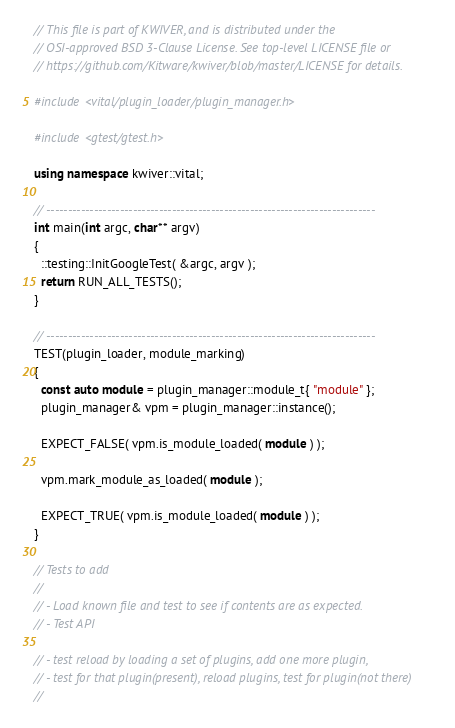<code> <loc_0><loc_0><loc_500><loc_500><_C++_>// This file is part of KWIVER, and is distributed under the
// OSI-approved BSD 3-Clause License. See top-level LICENSE file or
// https://github.com/Kitware/kwiver/blob/master/LICENSE for details.

#include <vital/plugin_loader/plugin_manager.h>

#include <gtest/gtest.h>

using namespace kwiver::vital;

// ----------------------------------------------------------------------------
int main(int argc, char** argv)
{
  ::testing::InitGoogleTest( &argc, argv );
  return RUN_ALL_TESTS();
}

// ----------------------------------------------------------------------------
TEST(plugin_loader, module_marking)
{
  const auto module = plugin_manager::module_t{ "module" };
  plugin_manager& vpm = plugin_manager::instance();

  EXPECT_FALSE( vpm.is_module_loaded( module ) );

  vpm.mark_module_as_loaded( module );

  EXPECT_TRUE( vpm.is_module_loaded( module ) );
}

// Tests to add
//
// - Load known file and test to see if contents are as expected.
// - Test API

// - test reload by loading a set of plugins, add one more plugin,
// - test for that plugin(present), reload plugins, test for plugin(not there)
//
</code> 